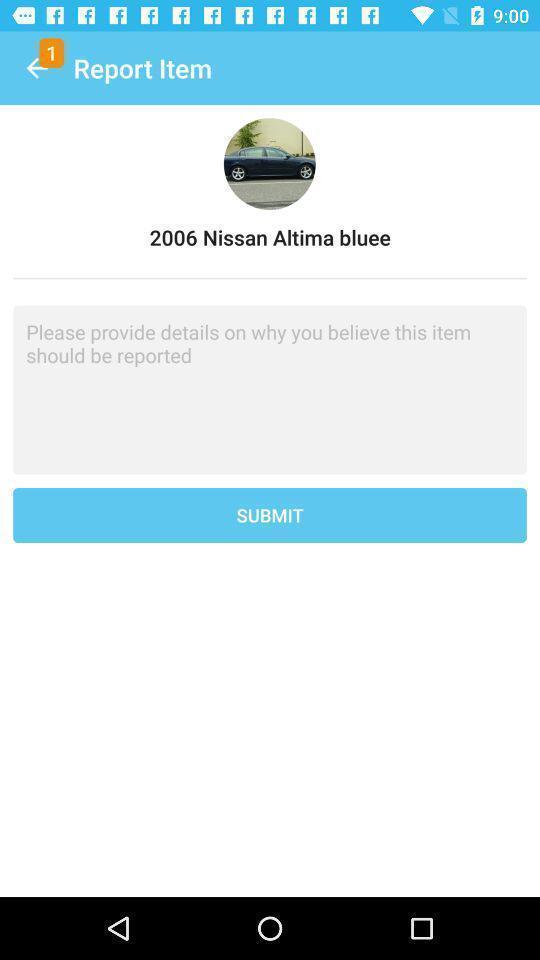Please provide a description for this image. Submit page for reporting an item. 